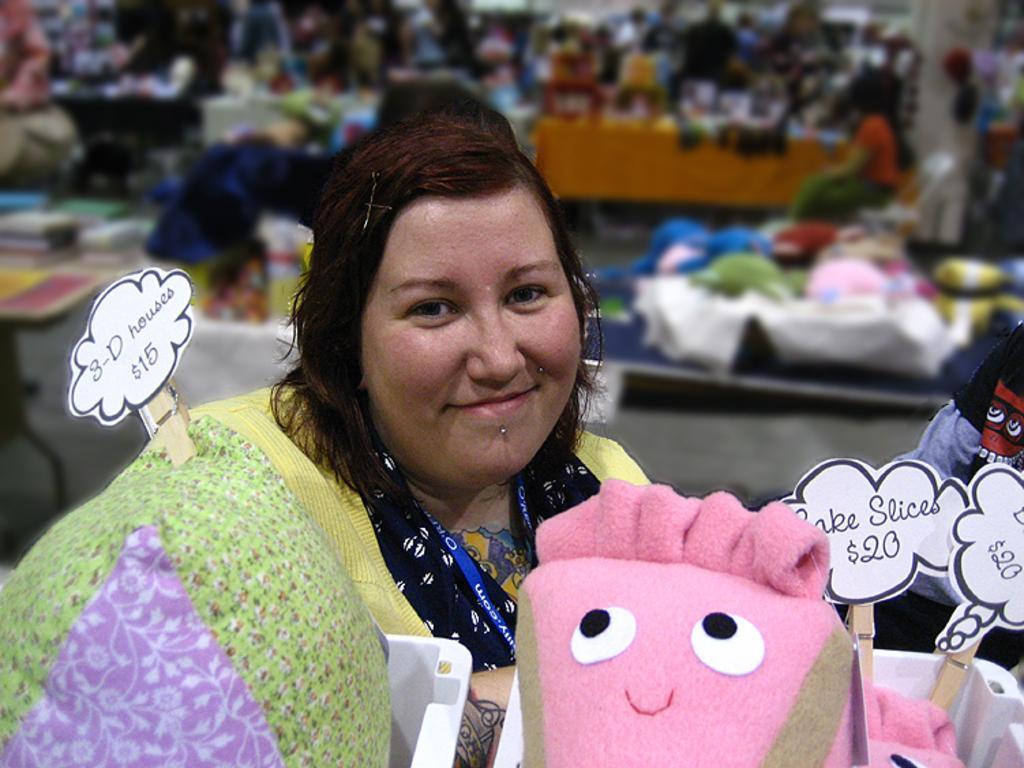Could you give a brief overview of what you see in this image? Here we can see a woman and she is smiling. There is a pillow, toy, and boards. There is a blur background and we can see few persons and objects. 